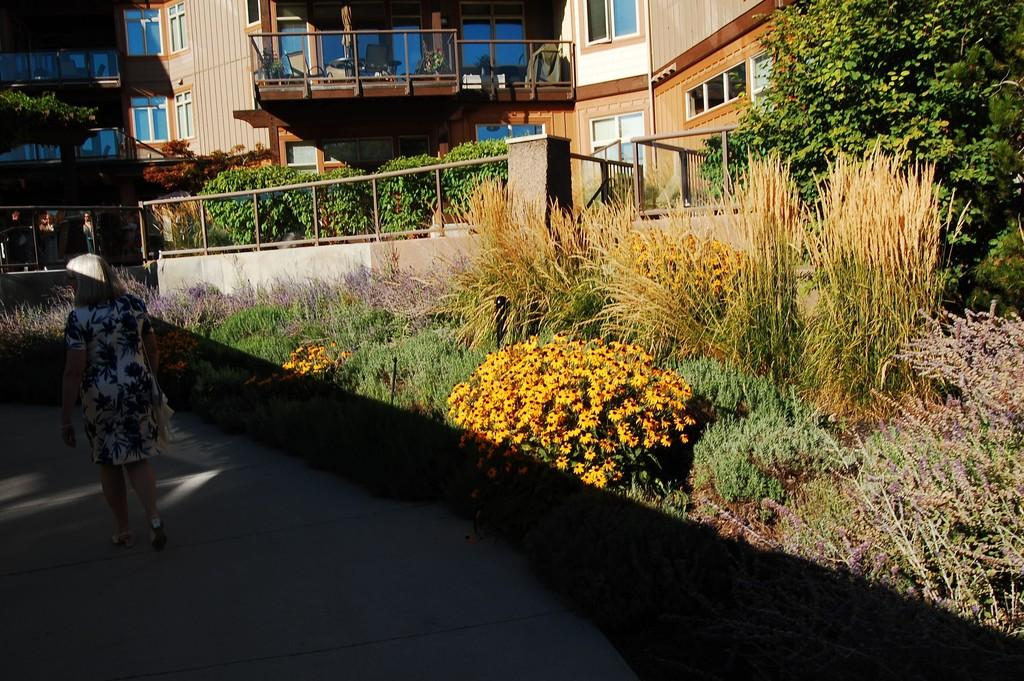What is the woman in the image doing? The woman is walking in the image. What surface is the woman walking on? The woman is walking on the ground. What type of vegetation can be seen in the image? There are flowers on the plants and trees in the image. Can any structures be identified in the background of the image? Yes, there are buildings visible in the background of the image. What type of noise can be heard coming from the pickle in the image? There is no pickle present in the image, so it's not possible to determine what noise might be associated with it. 